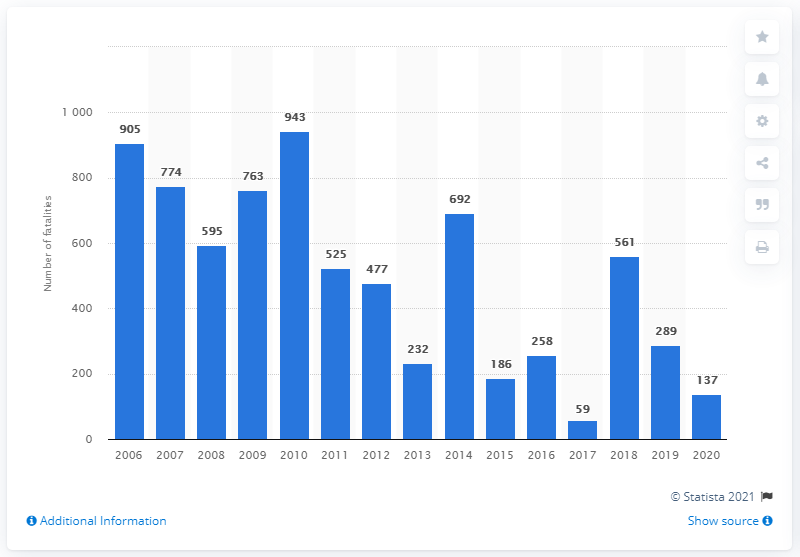List a handful of essential elements in this visual. In 2020, a total of 137 deaths were caused by air crashes. In 2020, a total of 137 deaths occurred due to air crashes. 